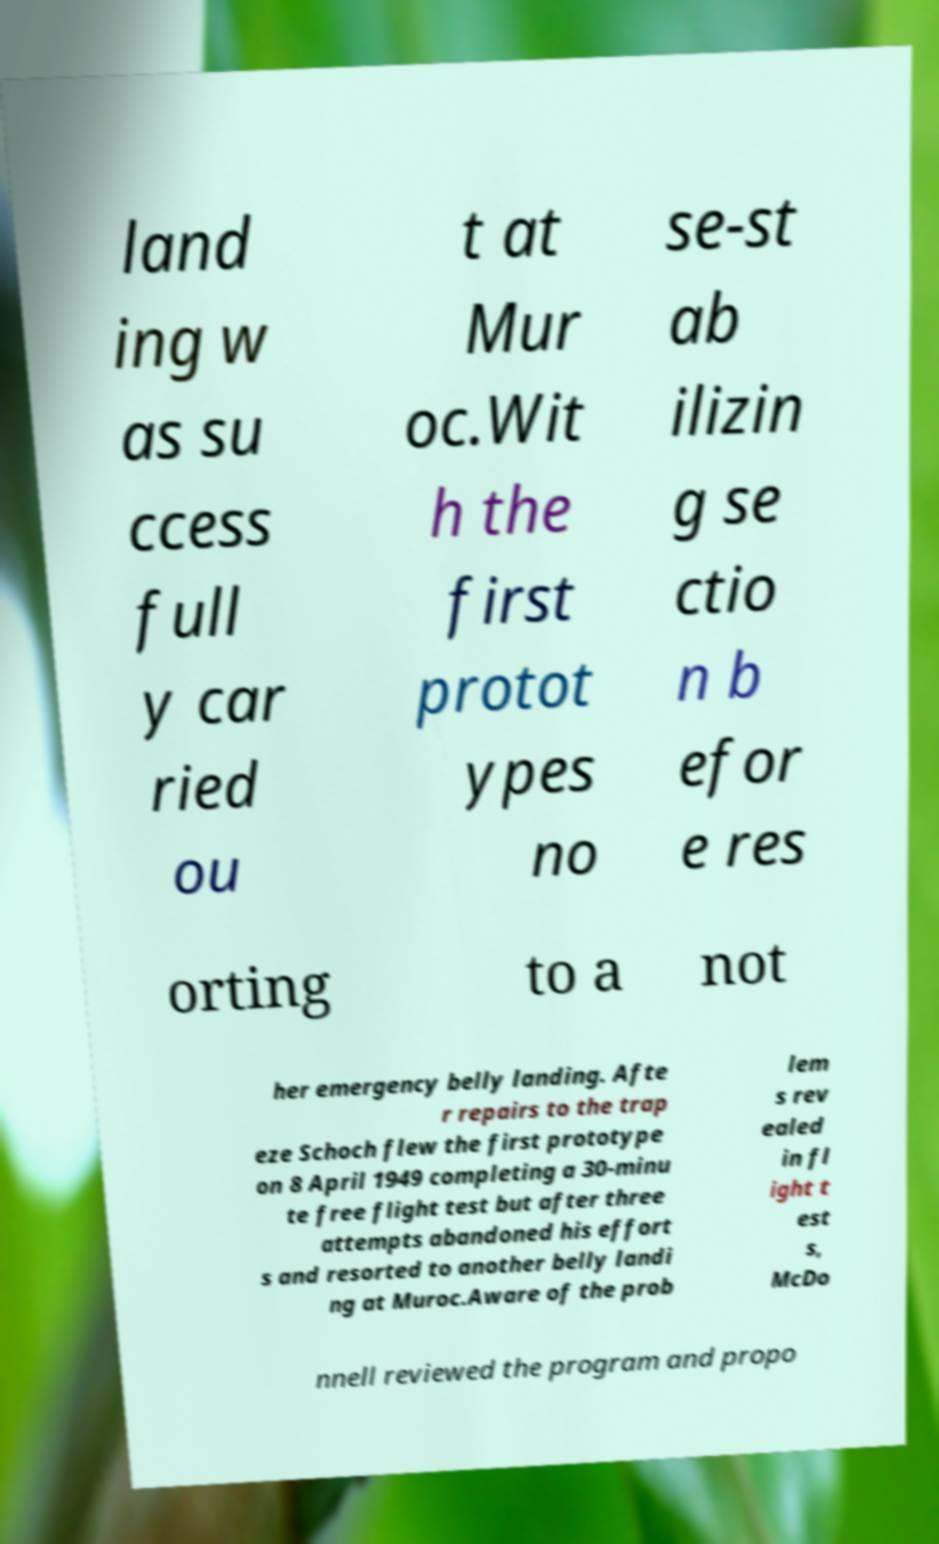There's text embedded in this image that I need extracted. Can you transcribe it verbatim? land ing w as su ccess full y car ried ou t at Mur oc.Wit h the first protot ypes no se-st ab ilizin g se ctio n b efor e res orting to a not her emergency belly landing. Afte r repairs to the trap eze Schoch flew the first prototype on 8 April 1949 completing a 30-minu te free flight test but after three attempts abandoned his effort s and resorted to another belly landi ng at Muroc.Aware of the prob lem s rev ealed in fl ight t est s, McDo nnell reviewed the program and propo 